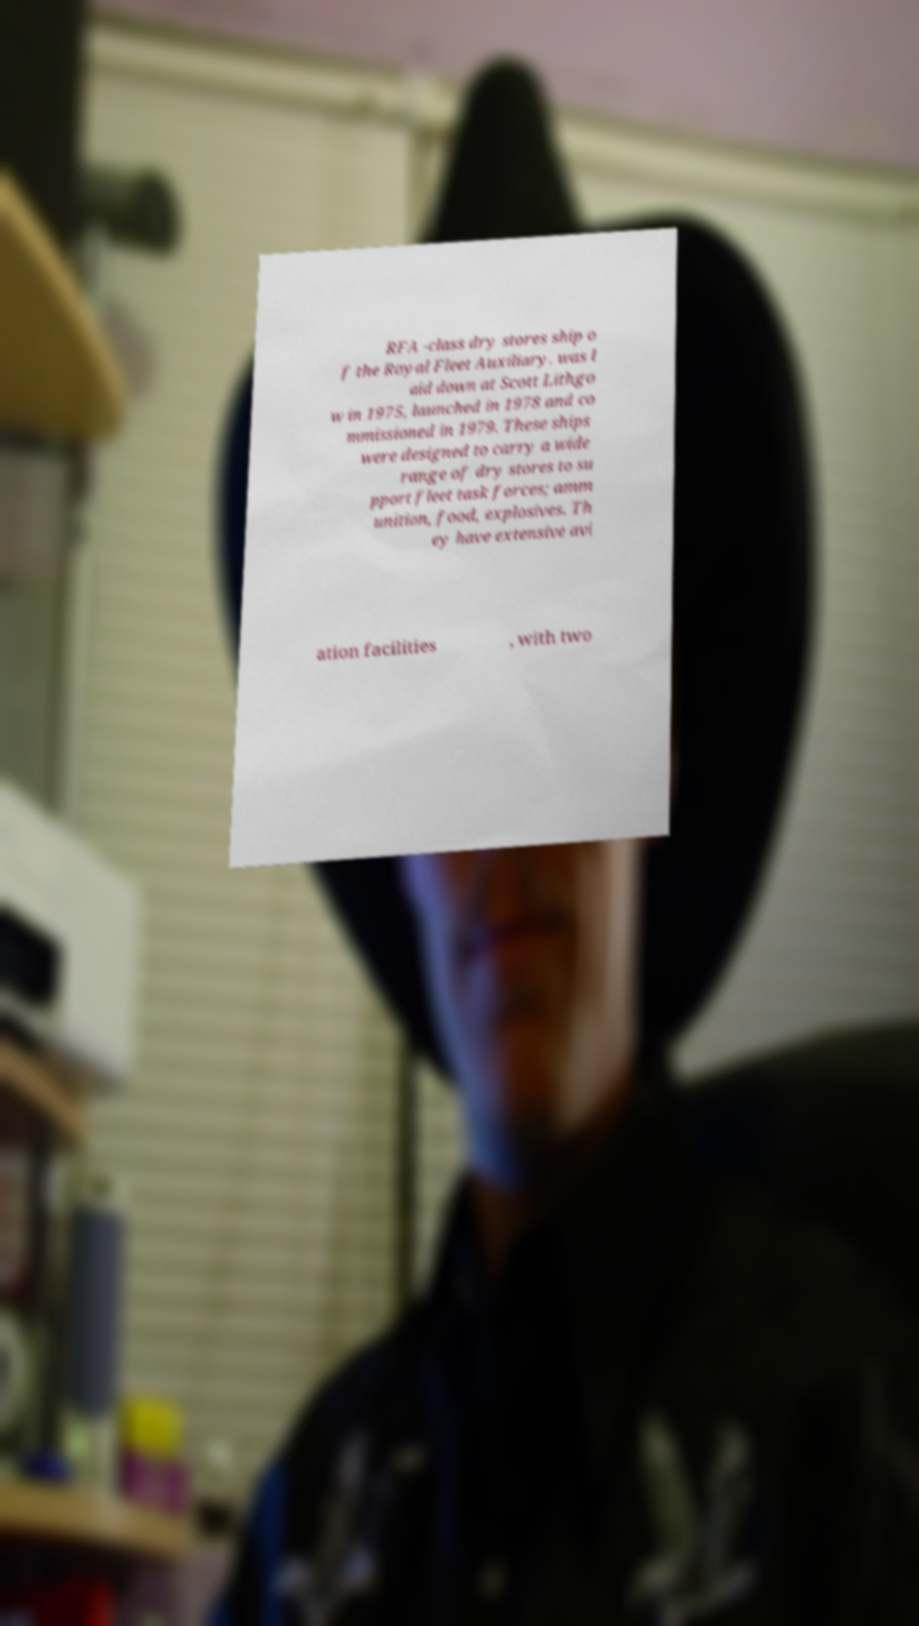I need the written content from this picture converted into text. Can you do that? RFA -class dry stores ship o f the Royal Fleet Auxiliary. was l aid down at Scott Lithgo w in 1975, launched in 1978 and co mmissioned in 1979. These ships were designed to carry a wide range of dry stores to su pport fleet task forces; amm unition, food, explosives. Th ey have extensive avi ation facilities , with two 